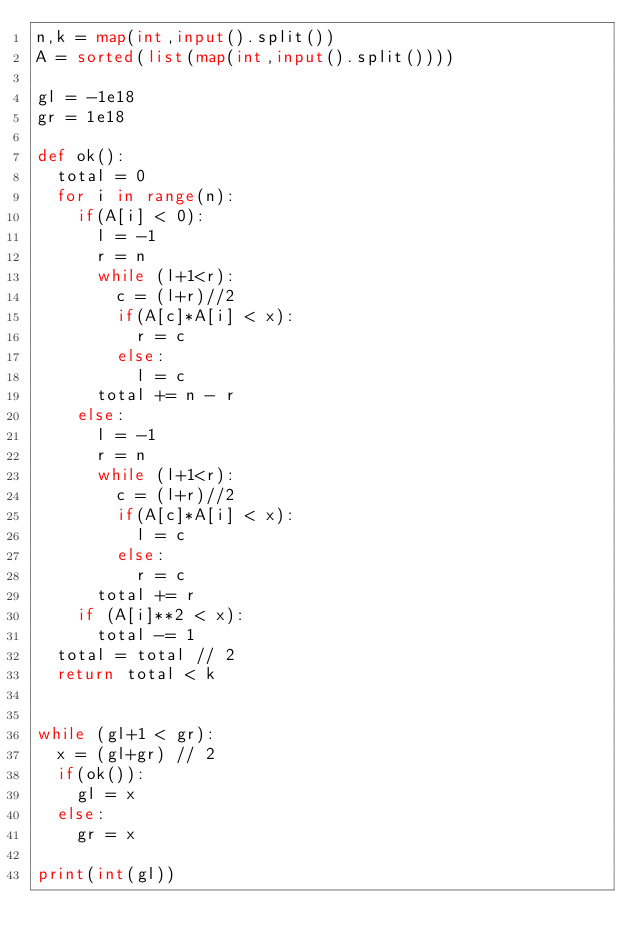Convert code to text. <code><loc_0><loc_0><loc_500><loc_500><_Python_>n,k = map(int,input().split())
A = sorted(list(map(int,input().split())))

gl = -1e18
gr = 1e18

def ok():
  total = 0
  for i in range(n):
    if(A[i] < 0):
      l = -1
      r = n
      while (l+1<r):
        c = (l+r)//2
        if(A[c]*A[i] < x):
          r = c
        else:
          l = c
      total += n - r
    else:
      l = -1
      r = n
      while (l+1<r):
        c = (l+r)//2
        if(A[c]*A[i] < x):
          l = c
        else:
          r = c
      total += r
    if (A[i]**2 < x):
      total -= 1
  total = total // 2
  return total < k
      

while (gl+1 < gr):
  x = (gl+gr) // 2
  if(ok()):
    gl = x
  else:
    gr = x
  
print(int(gl))</code> 